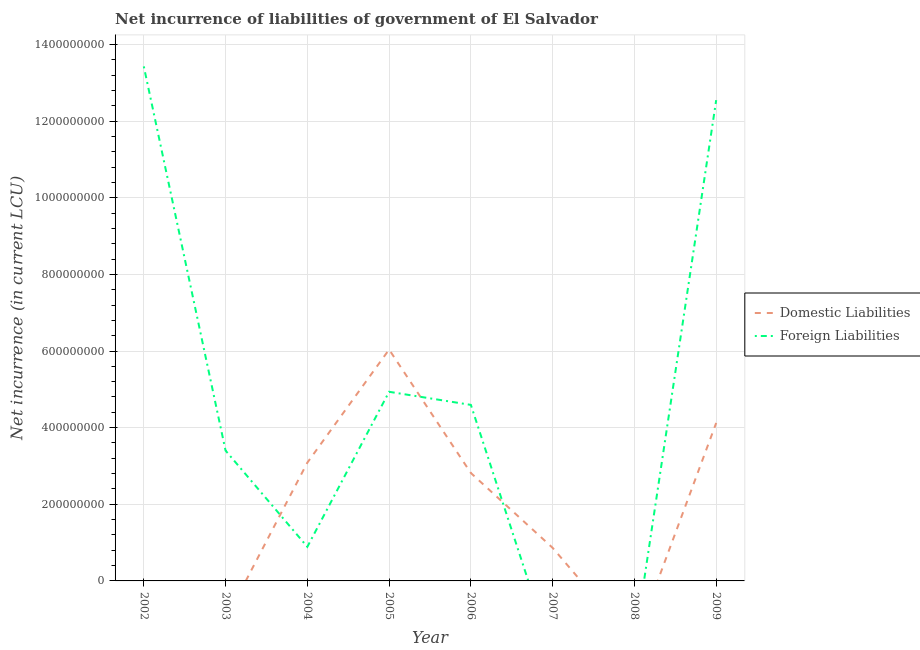Is the number of lines equal to the number of legend labels?
Provide a short and direct response. No. Across all years, what is the maximum net incurrence of domestic liabilities?
Keep it short and to the point. 6.04e+08. What is the total net incurrence of domestic liabilities in the graph?
Offer a very short reply. 1.69e+09. What is the difference between the net incurrence of domestic liabilities in 2005 and that in 2009?
Offer a very short reply. 1.92e+08. What is the difference between the net incurrence of foreign liabilities in 2009 and the net incurrence of domestic liabilities in 2008?
Make the answer very short. 1.25e+09. What is the average net incurrence of domestic liabilities per year?
Make the answer very short. 2.12e+08. In the year 2004, what is the difference between the net incurrence of domestic liabilities and net incurrence of foreign liabilities?
Your answer should be very brief. 2.20e+08. In how many years, is the net incurrence of foreign liabilities greater than 120000000 LCU?
Offer a terse response. 5. What is the ratio of the net incurrence of domestic liabilities in 2005 to that in 2006?
Give a very brief answer. 2.14. Is the net incurrence of domestic liabilities in 2004 less than that in 2009?
Provide a short and direct response. Yes. What is the difference between the highest and the second highest net incurrence of domestic liabilities?
Provide a succinct answer. 1.92e+08. What is the difference between the highest and the lowest net incurrence of domestic liabilities?
Offer a very short reply. 6.04e+08. Does the net incurrence of domestic liabilities monotonically increase over the years?
Your answer should be compact. No. How many years are there in the graph?
Offer a very short reply. 8. Does the graph contain any zero values?
Give a very brief answer. Yes. What is the title of the graph?
Ensure brevity in your answer.  Net incurrence of liabilities of government of El Salvador. Does "Attending school" appear as one of the legend labels in the graph?
Provide a short and direct response. No. What is the label or title of the Y-axis?
Offer a very short reply. Net incurrence (in current LCU). What is the Net incurrence (in current LCU) in Domestic Liabilities in 2002?
Your response must be concise. 0. What is the Net incurrence (in current LCU) of Foreign Liabilities in 2002?
Offer a terse response. 1.34e+09. What is the Net incurrence (in current LCU) in Foreign Liabilities in 2003?
Give a very brief answer. 3.40e+08. What is the Net incurrence (in current LCU) in Domestic Liabilities in 2004?
Offer a very short reply. 3.09e+08. What is the Net incurrence (in current LCU) in Foreign Liabilities in 2004?
Offer a very short reply. 8.90e+07. What is the Net incurrence (in current LCU) in Domestic Liabilities in 2005?
Provide a short and direct response. 6.04e+08. What is the Net incurrence (in current LCU) in Foreign Liabilities in 2005?
Your answer should be compact. 4.94e+08. What is the Net incurrence (in current LCU) in Domestic Liabilities in 2006?
Give a very brief answer. 2.82e+08. What is the Net incurrence (in current LCU) in Foreign Liabilities in 2006?
Provide a short and direct response. 4.59e+08. What is the Net incurrence (in current LCU) in Domestic Liabilities in 2007?
Your answer should be compact. 8.63e+07. What is the Net incurrence (in current LCU) of Foreign Liabilities in 2007?
Your answer should be compact. 0. What is the Net incurrence (in current LCU) in Domestic Liabilities in 2008?
Your answer should be very brief. 0. What is the Net incurrence (in current LCU) of Domestic Liabilities in 2009?
Give a very brief answer. 4.12e+08. What is the Net incurrence (in current LCU) in Foreign Liabilities in 2009?
Your answer should be very brief. 1.25e+09. Across all years, what is the maximum Net incurrence (in current LCU) of Domestic Liabilities?
Give a very brief answer. 6.04e+08. Across all years, what is the maximum Net incurrence (in current LCU) in Foreign Liabilities?
Provide a short and direct response. 1.34e+09. What is the total Net incurrence (in current LCU) of Domestic Liabilities in the graph?
Make the answer very short. 1.69e+09. What is the total Net incurrence (in current LCU) in Foreign Liabilities in the graph?
Your response must be concise. 3.98e+09. What is the difference between the Net incurrence (in current LCU) of Foreign Liabilities in 2002 and that in 2003?
Offer a terse response. 1.00e+09. What is the difference between the Net incurrence (in current LCU) of Foreign Liabilities in 2002 and that in 2004?
Provide a short and direct response. 1.25e+09. What is the difference between the Net incurrence (in current LCU) in Foreign Liabilities in 2002 and that in 2005?
Keep it short and to the point. 8.49e+08. What is the difference between the Net incurrence (in current LCU) in Foreign Liabilities in 2002 and that in 2006?
Your response must be concise. 8.83e+08. What is the difference between the Net incurrence (in current LCU) of Foreign Liabilities in 2002 and that in 2009?
Give a very brief answer. 8.80e+07. What is the difference between the Net incurrence (in current LCU) of Foreign Liabilities in 2003 and that in 2004?
Keep it short and to the point. 2.51e+08. What is the difference between the Net incurrence (in current LCU) in Foreign Liabilities in 2003 and that in 2005?
Provide a short and direct response. -1.54e+08. What is the difference between the Net incurrence (in current LCU) in Foreign Liabilities in 2003 and that in 2006?
Offer a very short reply. -1.19e+08. What is the difference between the Net incurrence (in current LCU) in Foreign Liabilities in 2003 and that in 2009?
Give a very brief answer. -9.15e+08. What is the difference between the Net incurrence (in current LCU) of Domestic Liabilities in 2004 and that in 2005?
Your answer should be very brief. -2.95e+08. What is the difference between the Net incurrence (in current LCU) of Foreign Liabilities in 2004 and that in 2005?
Provide a short and direct response. -4.05e+08. What is the difference between the Net incurrence (in current LCU) in Domestic Liabilities in 2004 and that in 2006?
Your response must be concise. 2.71e+07. What is the difference between the Net incurrence (in current LCU) in Foreign Liabilities in 2004 and that in 2006?
Ensure brevity in your answer.  -3.70e+08. What is the difference between the Net incurrence (in current LCU) in Domestic Liabilities in 2004 and that in 2007?
Provide a short and direct response. 2.22e+08. What is the difference between the Net incurrence (in current LCU) in Domestic Liabilities in 2004 and that in 2009?
Ensure brevity in your answer.  -1.04e+08. What is the difference between the Net incurrence (in current LCU) in Foreign Liabilities in 2004 and that in 2009?
Make the answer very short. -1.17e+09. What is the difference between the Net incurrence (in current LCU) of Domestic Liabilities in 2005 and that in 2006?
Your answer should be compact. 3.22e+08. What is the difference between the Net incurrence (in current LCU) of Foreign Liabilities in 2005 and that in 2006?
Offer a very short reply. 3.42e+07. What is the difference between the Net incurrence (in current LCU) in Domestic Liabilities in 2005 and that in 2007?
Give a very brief answer. 5.18e+08. What is the difference between the Net incurrence (in current LCU) of Domestic Liabilities in 2005 and that in 2009?
Offer a very short reply. 1.92e+08. What is the difference between the Net incurrence (in current LCU) in Foreign Liabilities in 2005 and that in 2009?
Your answer should be very brief. -7.61e+08. What is the difference between the Net incurrence (in current LCU) of Domestic Liabilities in 2006 and that in 2007?
Give a very brief answer. 1.95e+08. What is the difference between the Net incurrence (in current LCU) in Domestic Liabilities in 2006 and that in 2009?
Your response must be concise. -1.31e+08. What is the difference between the Net incurrence (in current LCU) of Foreign Liabilities in 2006 and that in 2009?
Your answer should be compact. -7.95e+08. What is the difference between the Net incurrence (in current LCU) in Domestic Liabilities in 2007 and that in 2009?
Ensure brevity in your answer.  -3.26e+08. What is the difference between the Net incurrence (in current LCU) in Domestic Liabilities in 2004 and the Net incurrence (in current LCU) in Foreign Liabilities in 2005?
Provide a succinct answer. -1.85e+08. What is the difference between the Net incurrence (in current LCU) in Domestic Liabilities in 2004 and the Net incurrence (in current LCU) in Foreign Liabilities in 2006?
Offer a very short reply. -1.51e+08. What is the difference between the Net incurrence (in current LCU) of Domestic Liabilities in 2004 and the Net incurrence (in current LCU) of Foreign Liabilities in 2009?
Provide a succinct answer. -9.46e+08. What is the difference between the Net incurrence (in current LCU) of Domestic Liabilities in 2005 and the Net incurrence (in current LCU) of Foreign Liabilities in 2006?
Your response must be concise. 1.44e+08. What is the difference between the Net incurrence (in current LCU) of Domestic Liabilities in 2005 and the Net incurrence (in current LCU) of Foreign Liabilities in 2009?
Keep it short and to the point. -6.51e+08. What is the difference between the Net incurrence (in current LCU) of Domestic Liabilities in 2006 and the Net incurrence (in current LCU) of Foreign Liabilities in 2009?
Give a very brief answer. -9.73e+08. What is the difference between the Net incurrence (in current LCU) of Domestic Liabilities in 2007 and the Net incurrence (in current LCU) of Foreign Liabilities in 2009?
Ensure brevity in your answer.  -1.17e+09. What is the average Net incurrence (in current LCU) in Domestic Liabilities per year?
Your response must be concise. 2.12e+08. What is the average Net incurrence (in current LCU) in Foreign Liabilities per year?
Make the answer very short. 4.97e+08. In the year 2004, what is the difference between the Net incurrence (in current LCU) of Domestic Liabilities and Net incurrence (in current LCU) of Foreign Liabilities?
Give a very brief answer. 2.20e+08. In the year 2005, what is the difference between the Net incurrence (in current LCU) of Domestic Liabilities and Net incurrence (in current LCU) of Foreign Liabilities?
Make the answer very short. 1.10e+08. In the year 2006, what is the difference between the Net incurrence (in current LCU) of Domestic Liabilities and Net incurrence (in current LCU) of Foreign Liabilities?
Give a very brief answer. -1.78e+08. In the year 2009, what is the difference between the Net incurrence (in current LCU) of Domestic Liabilities and Net incurrence (in current LCU) of Foreign Liabilities?
Give a very brief answer. -8.42e+08. What is the ratio of the Net incurrence (in current LCU) of Foreign Liabilities in 2002 to that in 2003?
Offer a terse response. 3.95. What is the ratio of the Net incurrence (in current LCU) in Foreign Liabilities in 2002 to that in 2004?
Make the answer very short. 15.09. What is the ratio of the Net incurrence (in current LCU) of Foreign Liabilities in 2002 to that in 2005?
Keep it short and to the point. 2.72. What is the ratio of the Net incurrence (in current LCU) in Foreign Liabilities in 2002 to that in 2006?
Your response must be concise. 2.92. What is the ratio of the Net incurrence (in current LCU) of Foreign Liabilities in 2002 to that in 2009?
Your answer should be compact. 1.07. What is the ratio of the Net incurrence (in current LCU) in Foreign Liabilities in 2003 to that in 2004?
Ensure brevity in your answer.  3.82. What is the ratio of the Net incurrence (in current LCU) of Foreign Liabilities in 2003 to that in 2005?
Offer a terse response. 0.69. What is the ratio of the Net incurrence (in current LCU) of Foreign Liabilities in 2003 to that in 2006?
Your answer should be compact. 0.74. What is the ratio of the Net incurrence (in current LCU) in Foreign Liabilities in 2003 to that in 2009?
Keep it short and to the point. 0.27. What is the ratio of the Net incurrence (in current LCU) of Domestic Liabilities in 2004 to that in 2005?
Offer a very short reply. 0.51. What is the ratio of the Net incurrence (in current LCU) in Foreign Liabilities in 2004 to that in 2005?
Offer a very short reply. 0.18. What is the ratio of the Net incurrence (in current LCU) of Domestic Liabilities in 2004 to that in 2006?
Provide a succinct answer. 1.1. What is the ratio of the Net incurrence (in current LCU) in Foreign Liabilities in 2004 to that in 2006?
Provide a short and direct response. 0.19. What is the ratio of the Net incurrence (in current LCU) of Domestic Liabilities in 2004 to that in 2007?
Ensure brevity in your answer.  3.58. What is the ratio of the Net incurrence (in current LCU) of Domestic Liabilities in 2004 to that in 2009?
Offer a terse response. 0.75. What is the ratio of the Net incurrence (in current LCU) in Foreign Liabilities in 2004 to that in 2009?
Offer a very short reply. 0.07. What is the ratio of the Net incurrence (in current LCU) in Domestic Liabilities in 2005 to that in 2006?
Make the answer very short. 2.14. What is the ratio of the Net incurrence (in current LCU) in Foreign Liabilities in 2005 to that in 2006?
Provide a short and direct response. 1.07. What is the ratio of the Net incurrence (in current LCU) of Domestic Liabilities in 2005 to that in 2007?
Your answer should be compact. 7. What is the ratio of the Net incurrence (in current LCU) in Domestic Liabilities in 2005 to that in 2009?
Your answer should be compact. 1.46. What is the ratio of the Net incurrence (in current LCU) in Foreign Liabilities in 2005 to that in 2009?
Provide a short and direct response. 0.39. What is the ratio of the Net incurrence (in current LCU) in Domestic Liabilities in 2006 to that in 2007?
Make the answer very short. 3.26. What is the ratio of the Net incurrence (in current LCU) in Domestic Liabilities in 2006 to that in 2009?
Give a very brief answer. 0.68. What is the ratio of the Net incurrence (in current LCU) of Foreign Liabilities in 2006 to that in 2009?
Offer a very short reply. 0.37. What is the ratio of the Net incurrence (in current LCU) of Domestic Liabilities in 2007 to that in 2009?
Ensure brevity in your answer.  0.21. What is the difference between the highest and the second highest Net incurrence (in current LCU) of Domestic Liabilities?
Your answer should be compact. 1.92e+08. What is the difference between the highest and the second highest Net incurrence (in current LCU) of Foreign Liabilities?
Your response must be concise. 8.80e+07. What is the difference between the highest and the lowest Net incurrence (in current LCU) of Domestic Liabilities?
Your answer should be very brief. 6.04e+08. What is the difference between the highest and the lowest Net incurrence (in current LCU) of Foreign Liabilities?
Your answer should be very brief. 1.34e+09. 